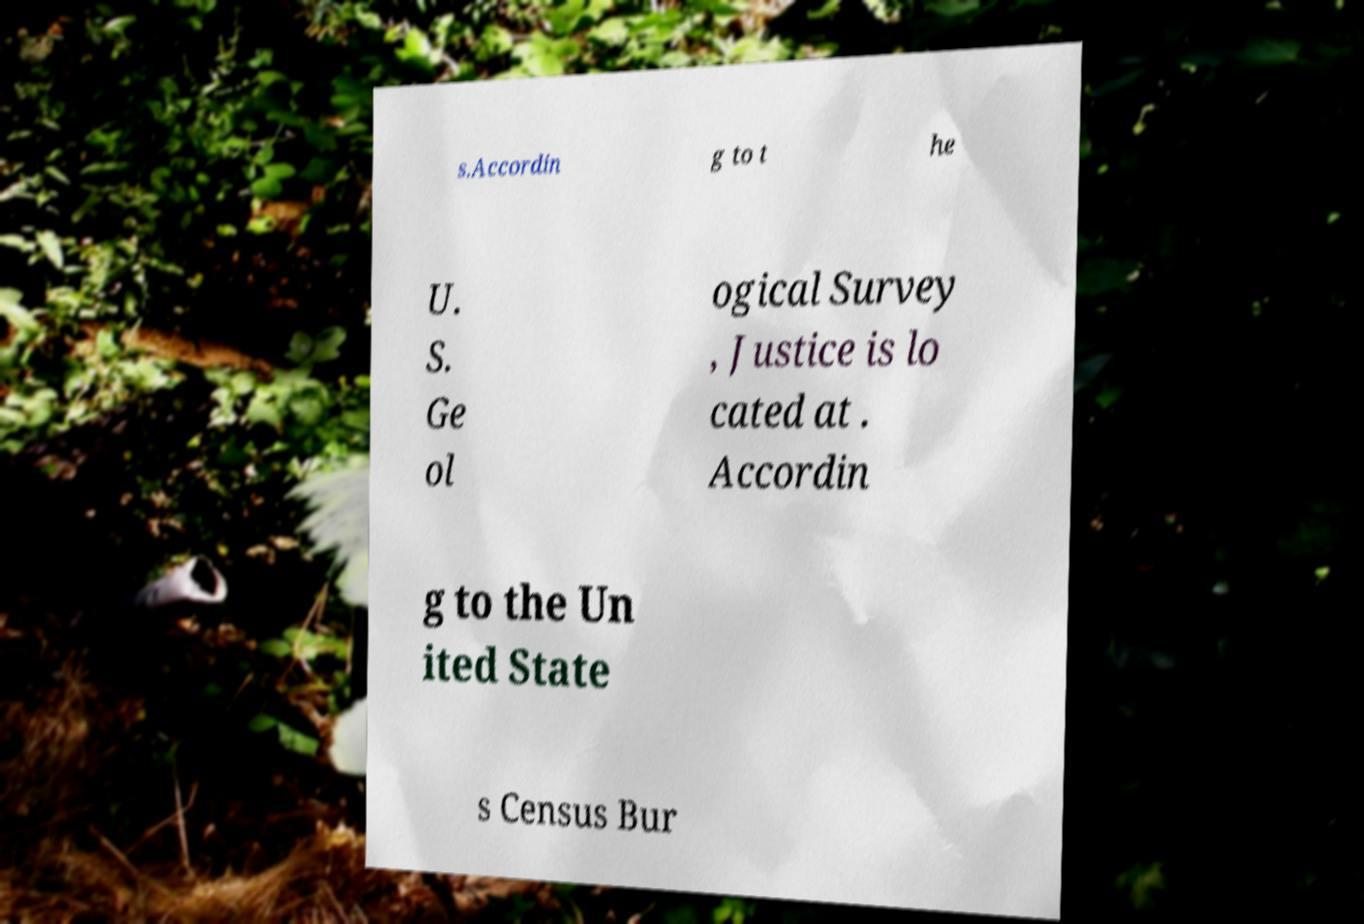Can you accurately transcribe the text from the provided image for me? s.Accordin g to t he U. S. Ge ol ogical Survey , Justice is lo cated at . Accordin g to the Un ited State s Census Bur 